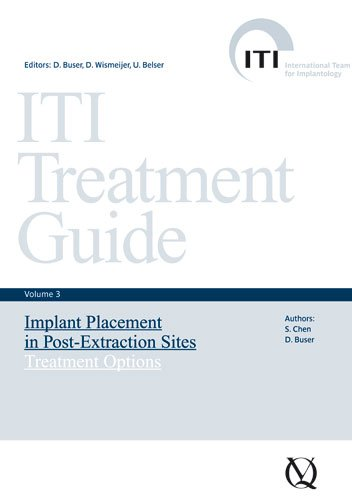Who wrote this book? This book lists several contributors including S. Chen, D. Buser, and others, focusing on expertise in dental implantology. 